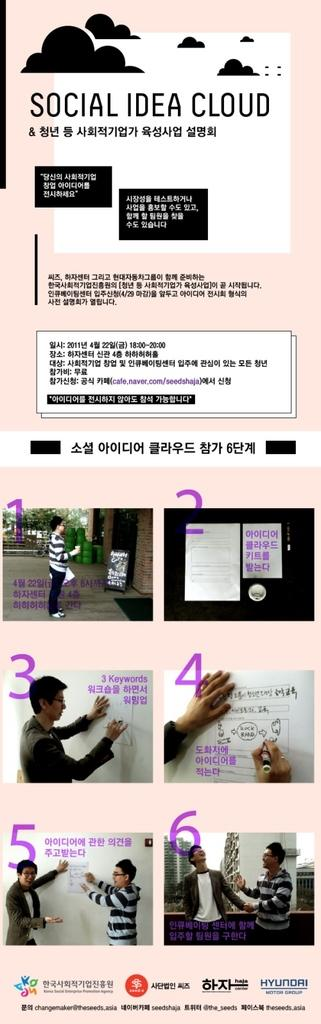What type of visual is the image? The image is a poster. Who or what can be seen on the poster? There are persons depicted on the poster. What else is present on the poster besides the images of persons? There is text written on the poster. What type of profit can be seen in the image? There is no profit depicted in the image; it is a poster featuring persons and text. What kind of party is taking place in the image? There is no party depicted in the image; it is a poster with persons and text. 